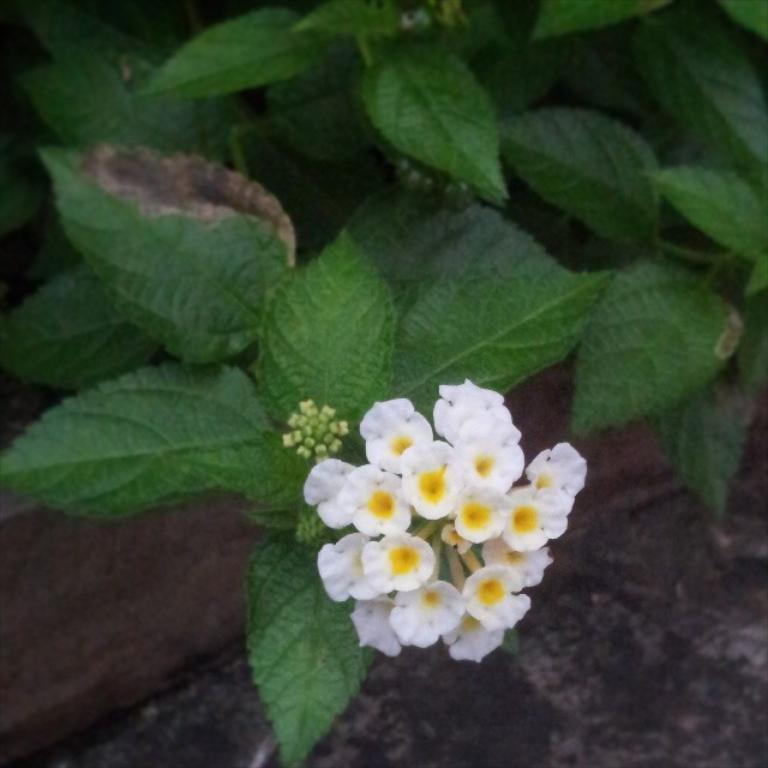Could you give a brief overview of what you see in this image? In this image I can see white colour flowers and green colour leaves. 